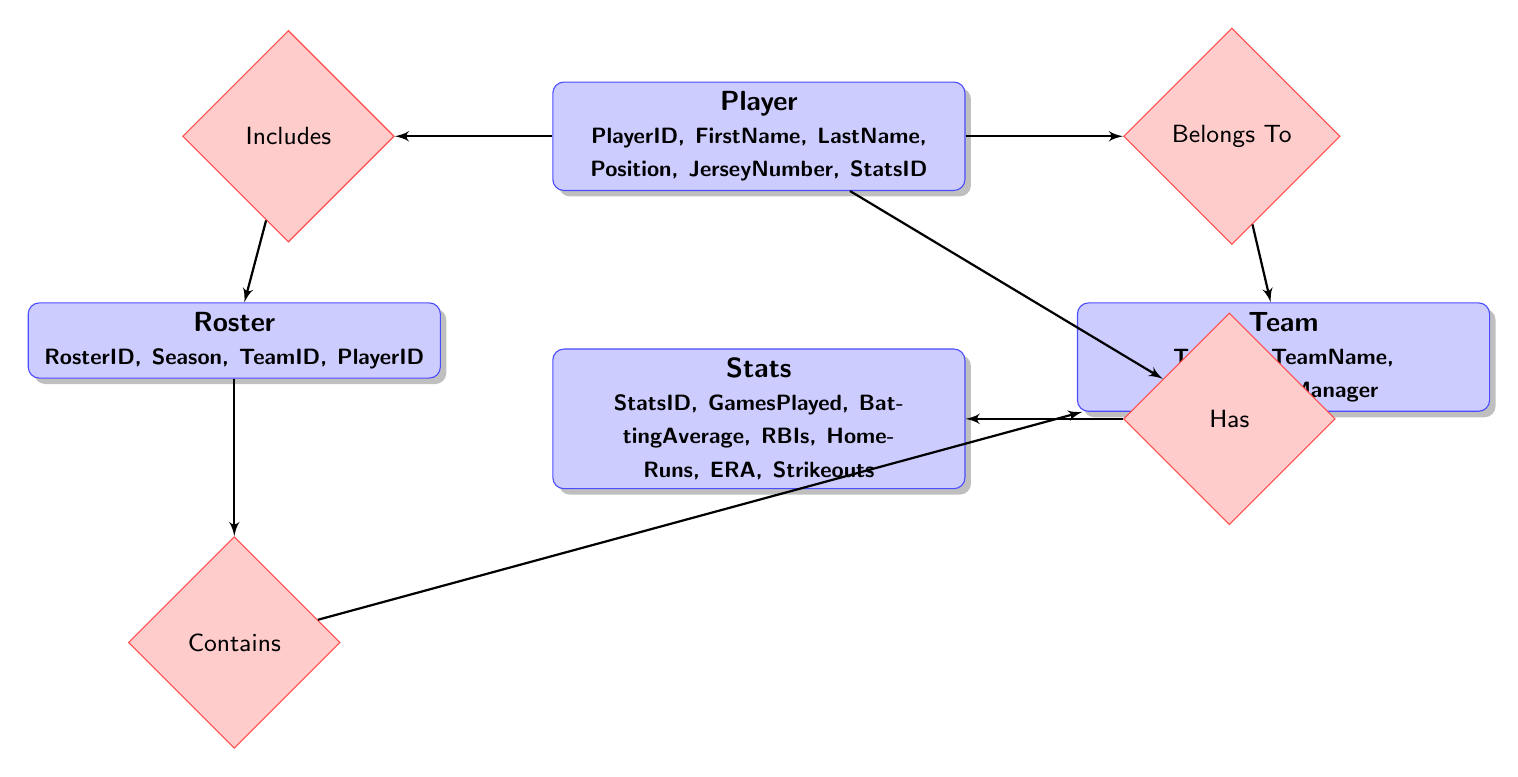What is the name of the relationship between Player and Team? The diagram includes a relationship labeled "Belongs To" which connects the Player entity to the Team entity. This indicates the association where each player is part of a specific team.
Answer: Belongs To How many total entities are present in the diagram? By counting the entities listed in the diagram, we find there are four entities: Player, Team, Roster, and Stats.
Answer: 4 Which entity includes the attribute "JerseyNumber"? The Player entity contains the attribute "JerseyNumber," as shown in the attributes section of the Player node in the diagram.
Answer: Player How does a Player relate to Stats? The relationship labeled "Has" connects the Player entity to the Stats entity, indicating that each player has specific statistics associated with their performance.
Answer: Has What attribute is common between Player and Stats? The common attribute that links Player and Stats is "StatsID," which is used in the Player entity to reference the Stats entity, highlighting the performance metrics of the player.
Answer: StatsID Which entity contains the attribute "TeamName"? "TeamName" is an attribute of the Team entity, as indicated in the attributes section provided for the Team node in the diagram.
Answer: Team How many relationships are connecting the Roster to other entities? There are two relationships connecting the Roster entity to other entities, specifically "Includes" with Player and "Contains" with Team, showing how a roster comprises players and is associated with a team.
Answer: 2 What is the primary function of the Roster entity? The Roster entity acts as a linking entity that connects Players with a Team for a specific Season, encapsulating this association in the context of team organization.
Answer: Team organization Which entity attributes are relevant for a player's performance metrics? The relevant attributes for a player's performance are found in the Stats entity and include GamesPlayed, BattingAverage, RBIs, HomeRuns, ERA, and Strikeouts, detailing various performance indicators.
Answer: Stats attributes 